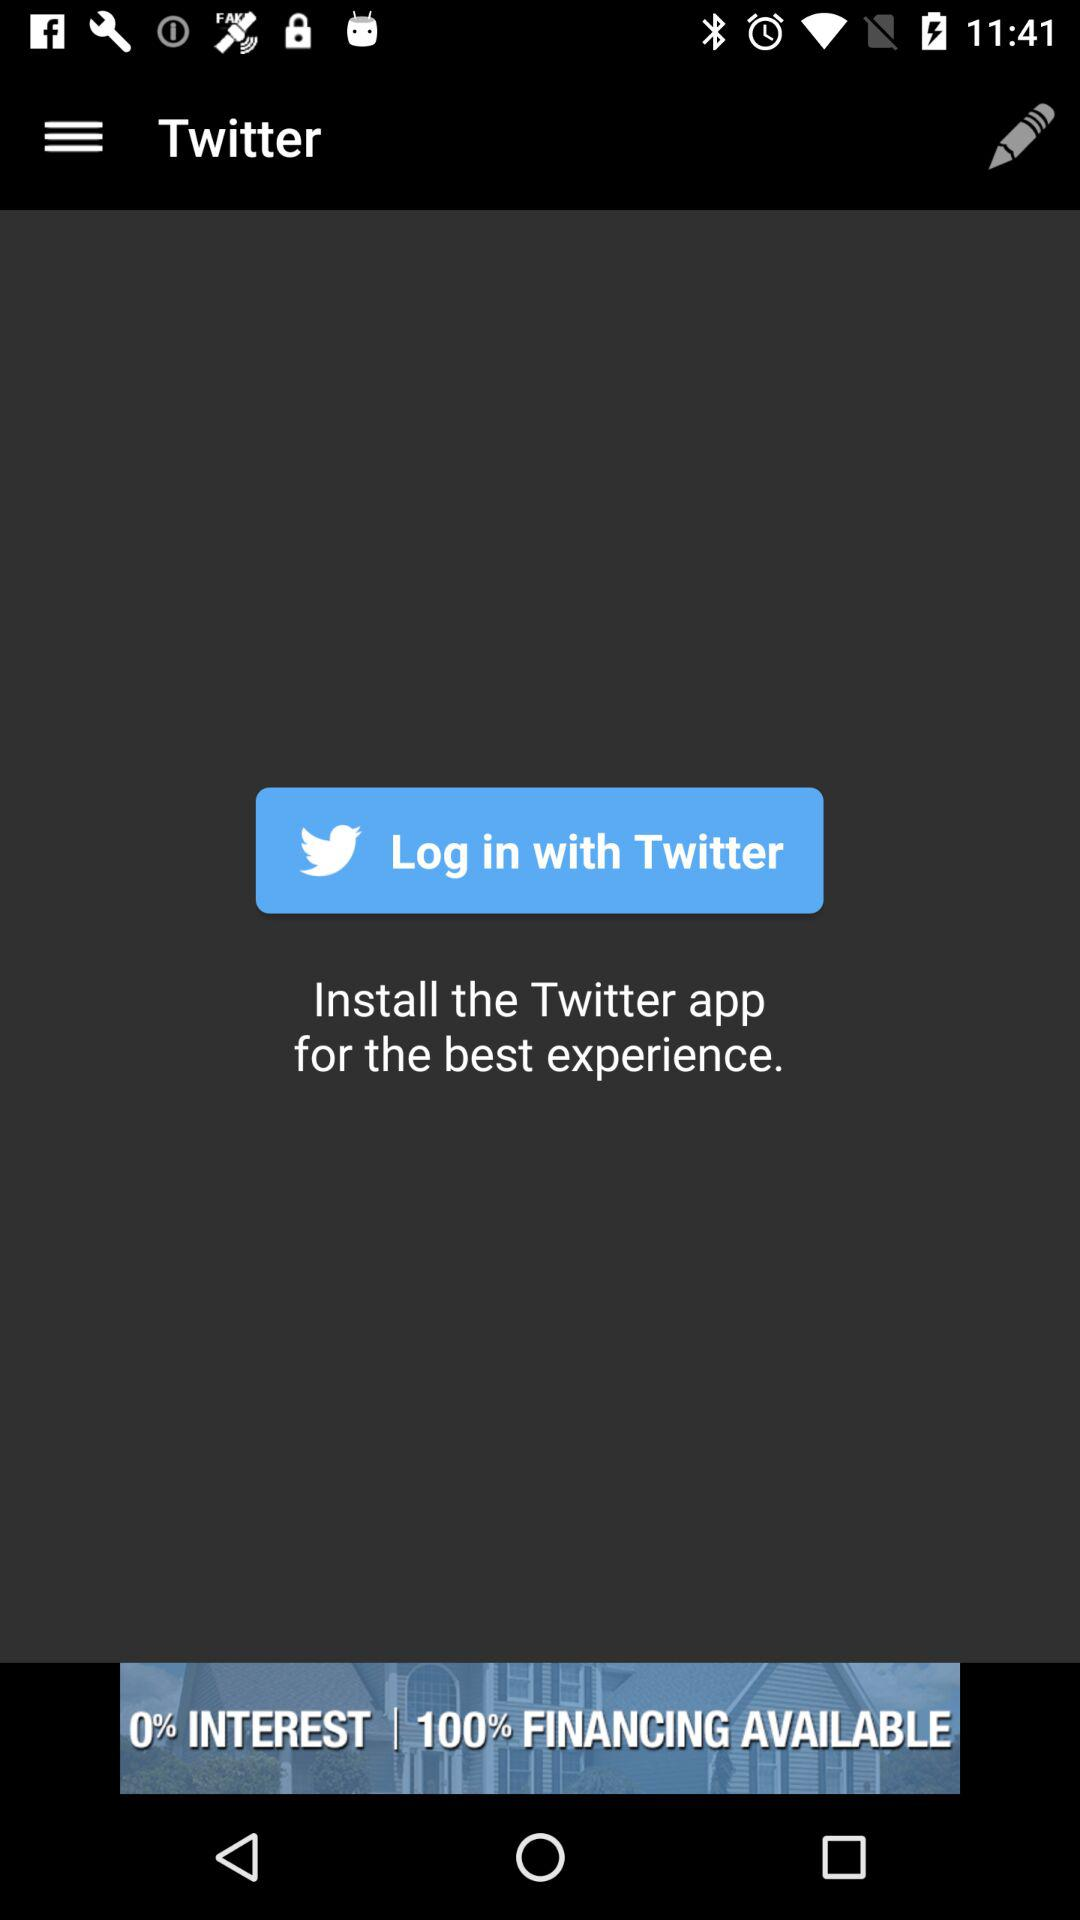If the interest rate is 0%, then what is the percentage of financing available?
Answer the question using a single word or phrase. 100% 